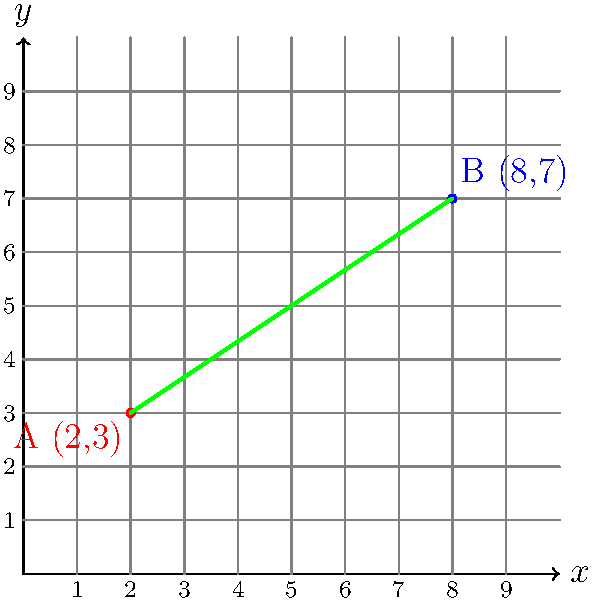In a panel from your favorite graphic novel, two characters are positioned at different points on a coordinate plane. Character A is at point (2,3), and Character B is at point (8,7). What is the slope of the line connecting these two characters? To find the slope of the line connecting two points, we use the slope formula:

$$ m = \frac{y_2 - y_1}{x_2 - x_1} $$

Where $(x_1, y_1)$ is the first point and $(x_2, y_2)$ is the second point.

Given:
- Character A is at (2,3), so $x_1 = 2$ and $y_1 = 3$
- Character B is at (8,7), so $x_2 = 8$ and $y_2 = 7$

Let's plug these values into the slope formula:

$$ m = \frac{7 - 3}{8 - 2} = \frac{4}{6} $$

Simplifying the fraction:

$$ m = \frac{4}{6} = \frac{2}{3} $$

Therefore, the slope of the line connecting the two characters is $\frac{2}{3}$.
Answer: $\frac{2}{3}$ 